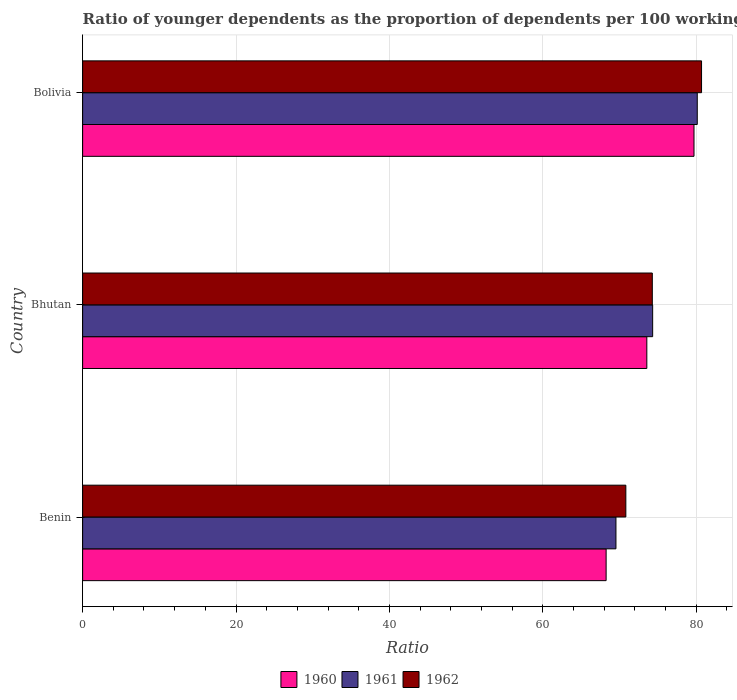How many groups of bars are there?
Give a very brief answer. 3. How many bars are there on the 3rd tick from the top?
Offer a terse response. 3. How many bars are there on the 1st tick from the bottom?
Offer a very short reply. 3. In how many cases, is the number of bars for a given country not equal to the number of legend labels?
Your answer should be very brief. 0. What is the age dependency ratio(young) in 1962 in Bhutan?
Provide a succinct answer. 74.29. Across all countries, what is the maximum age dependency ratio(young) in 1961?
Your response must be concise. 80.15. Across all countries, what is the minimum age dependency ratio(young) in 1961?
Make the answer very short. 69.54. In which country was the age dependency ratio(young) in 1962 maximum?
Your answer should be compact. Bolivia. In which country was the age dependency ratio(young) in 1961 minimum?
Provide a short and direct response. Benin. What is the total age dependency ratio(young) in 1962 in the graph?
Your answer should be compact. 225.83. What is the difference between the age dependency ratio(young) in 1961 in Bhutan and that in Bolivia?
Offer a very short reply. -5.82. What is the difference between the age dependency ratio(young) in 1961 in Bolivia and the age dependency ratio(young) in 1962 in Benin?
Make the answer very short. 9.31. What is the average age dependency ratio(young) in 1961 per country?
Give a very brief answer. 74.67. What is the difference between the age dependency ratio(young) in 1962 and age dependency ratio(young) in 1960 in Benin?
Your answer should be very brief. 2.57. What is the ratio of the age dependency ratio(young) in 1960 in Benin to that in Bolivia?
Make the answer very short. 0.86. Is the age dependency ratio(young) in 1960 in Bhutan less than that in Bolivia?
Offer a terse response. Yes. Is the difference between the age dependency ratio(young) in 1962 in Benin and Bhutan greater than the difference between the age dependency ratio(young) in 1960 in Benin and Bhutan?
Make the answer very short. Yes. What is the difference between the highest and the second highest age dependency ratio(young) in 1962?
Your answer should be compact. 6.42. What is the difference between the highest and the lowest age dependency ratio(young) in 1960?
Keep it short and to the point. 11.46. In how many countries, is the age dependency ratio(young) in 1960 greater than the average age dependency ratio(young) in 1960 taken over all countries?
Offer a terse response. 1. Is the sum of the age dependency ratio(young) in 1962 in Benin and Bhutan greater than the maximum age dependency ratio(young) in 1960 across all countries?
Keep it short and to the point. Yes. What does the 3rd bar from the bottom in Bolivia represents?
Provide a short and direct response. 1962. How many bars are there?
Provide a short and direct response. 9. Are the values on the major ticks of X-axis written in scientific E-notation?
Ensure brevity in your answer.  No. Does the graph contain any zero values?
Ensure brevity in your answer.  No. Does the graph contain grids?
Provide a short and direct response. Yes. How are the legend labels stacked?
Provide a short and direct response. Horizontal. What is the title of the graph?
Make the answer very short. Ratio of younger dependents as the proportion of dependents per 100 working-age population. Does "2008" appear as one of the legend labels in the graph?
Your answer should be very brief. No. What is the label or title of the X-axis?
Your response must be concise. Ratio. What is the Ratio in 1960 in Benin?
Your answer should be very brief. 68.26. What is the Ratio of 1961 in Benin?
Offer a terse response. 69.54. What is the Ratio of 1962 in Benin?
Provide a succinct answer. 70.83. What is the Ratio in 1960 in Bhutan?
Your answer should be compact. 73.57. What is the Ratio of 1961 in Bhutan?
Keep it short and to the point. 74.33. What is the Ratio of 1962 in Bhutan?
Make the answer very short. 74.29. What is the Ratio of 1960 in Bolivia?
Keep it short and to the point. 79.72. What is the Ratio in 1961 in Bolivia?
Provide a succinct answer. 80.15. What is the Ratio of 1962 in Bolivia?
Keep it short and to the point. 80.71. Across all countries, what is the maximum Ratio of 1960?
Your response must be concise. 79.72. Across all countries, what is the maximum Ratio in 1961?
Provide a succinct answer. 80.15. Across all countries, what is the maximum Ratio of 1962?
Your answer should be very brief. 80.71. Across all countries, what is the minimum Ratio of 1960?
Provide a succinct answer. 68.26. Across all countries, what is the minimum Ratio of 1961?
Offer a terse response. 69.54. Across all countries, what is the minimum Ratio in 1962?
Make the answer very short. 70.83. What is the total Ratio in 1960 in the graph?
Your answer should be very brief. 221.55. What is the total Ratio in 1961 in the graph?
Ensure brevity in your answer.  224.02. What is the total Ratio of 1962 in the graph?
Your response must be concise. 225.83. What is the difference between the Ratio in 1960 in Benin and that in Bhutan?
Give a very brief answer. -5.31. What is the difference between the Ratio in 1961 in Benin and that in Bhutan?
Offer a terse response. -4.79. What is the difference between the Ratio in 1962 in Benin and that in Bhutan?
Your response must be concise. -3.45. What is the difference between the Ratio in 1960 in Benin and that in Bolivia?
Give a very brief answer. -11.46. What is the difference between the Ratio in 1961 in Benin and that in Bolivia?
Make the answer very short. -10.6. What is the difference between the Ratio of 1962 in Benin and that in Bolivia?
Your response must be concise. -9.87. What is the difference between the Ratio in 1960 in Bhutan and that in Bolivia?
Offer a terse response. -6.15. What is the difference between the Ratio of 1961 in Bhutan and that in Bolivia?
Make the answer very short. -5.82. What is the difference between the Ratio in 1962 in Bhutan and that in Bolivia?
Your response must be concise. -6.42. What is the difference between the Ratio of 1960 in Benin and the Ratio of 1961 in Bhutan?
Provide a short and direct response. -6.07. What is the difference between the Ratio of 1960 in Benin and the Ratio of 1962 in Bhutan?
Offer a terse response. -6.02. What is the difference between the Ratio of 1961 in Benin and the Ratio of 1962 in Bhutan?
Your answer should be compact. -4.74. What is the difference between the Ratio in 1960 in Benin and the Ratio in 1961 in Bolivia?
Provide a succinct answer. -11.88. What is the difference between the Ratio in 1960 in Benin and the Ratio in 1962 in Bolivia?
Provide a short and direct response. -12.44. What is the difference between the Ratio of 1961 in Benin and the Ratio of 1962 in Bolivia?
Offer a very short reply. -11.16. What is the difference between the Ratio of 1960 in Bhutan and the Ratio of 1961 in Bolivia?
Offer a very short reply. -6.58. What is the difference between the Ratio of 1960 in Bhutan and the Ratio of 1962 in Bolivia?
Keep it short and to the point. -7.14. What is the difference between the Ratio in 1961 in Bhutan and the Ratio in 1962 in Bolivia?
Keep it short and to the point. -6.37. What is the average Ratio in 1960 per country?
Offer a terse response. 73.85. What is the average Ratio of 1961 per country?
Your answer should be very brief. 74.67. What is the average Ratio of 1962 per country?
Give a very brief answer. 75.28. What is the difference between the Ratio of 1960 and Ratio of 1961 in Benin?
Make the answer very short. -1.28. What is the difference between the Ratio of 1960 and Ratio of 1962 in Benin?
Offer a terse response. -2.57. What is the difference between the Ratio of 1961 and Ratio of 1962 in Benin?
Ensure brevity in your answer.  -1.29. What is the difference between the Ratio of 1960 and Ratio of 1961 in Bhutan?
Ensure brevity in your answer.  -0.76. What is the difference between the Ratio in 1960 and Ratio in 1962 in Bhutan?
Offer a very short reply. -0.72. What is the difference between the Ratio of 1961 and Ratio of 1962 in Bhutan?
Keep it short and to the point. 0.04. What is the difference between the Ratio of 1960 and Ratio of 1961 in Bolivia?
Ensure brevity in your answer.  -0.43. What is the difference between the Ratio in 1960 and Ratio in 1962 in Bolivia?
Provide a short and direct response. -0.98. What is the difference between the Ratio in 1961 and Ratio in 1962 in Bolivia?
Your answer should be very brief. -0.56. What is the ratio of the Ratio in 1960 in Benin to that in Bhutan?
Your response must be concise. 0.93. What is the ratio of the Ratio of 1961 in Benin to that in Bhutan?
Offer a terse response. 0.94. What is the ratio of the Ratio in 1962 in Benin to that in Bhutan?
Keep it short and to the point. 0.95. What is the ratio of the Ratio in 1960 in Benin to that in Bolivia?
Provide a succinct answer. 0.86. What is the ratio of the Ratio in 1961 in Benin to that in Bolivia?
Give a very brief answer. 0.87. What is the ratio of the Ratio in 1962 in Benin to that in Bolivia?
Offer a very short reply. 0.88. What is the ratio of the Ratio of 1960 in Bhutan to that in Bolivia?
Provide a short and direct response. 0.92. What is the ratio of the Ratio of 1961 in Bhutan to that in Bolivia?
Offer a terse response. 0.93. What is the ratio of the Ratio of 1962 in Bhutan to that in Bolivia?
Give a very brief answer. 0.92. What is the difference between the highest and the second highest Ratio in 1960?
Your answer should be very brief. 6.15. What is the difference between the highest and the second highest Ratio in 1961?
Your answer should be very brief. 5.82. What is the difference between the highest and the second highest Ratio of 1962?
Provide a succinct answer. 6.42. What is the difference between the highest and the lowest Ratio in 1960?
Offer a terse response. 11.46. What is the difference between the highest and the lowest Ratio of 1961?
Your answer should be very brief. 10.6. What is the difference between the highest and the lowest Ratio of 1962?
Keep it short and to the point. 9.87. 